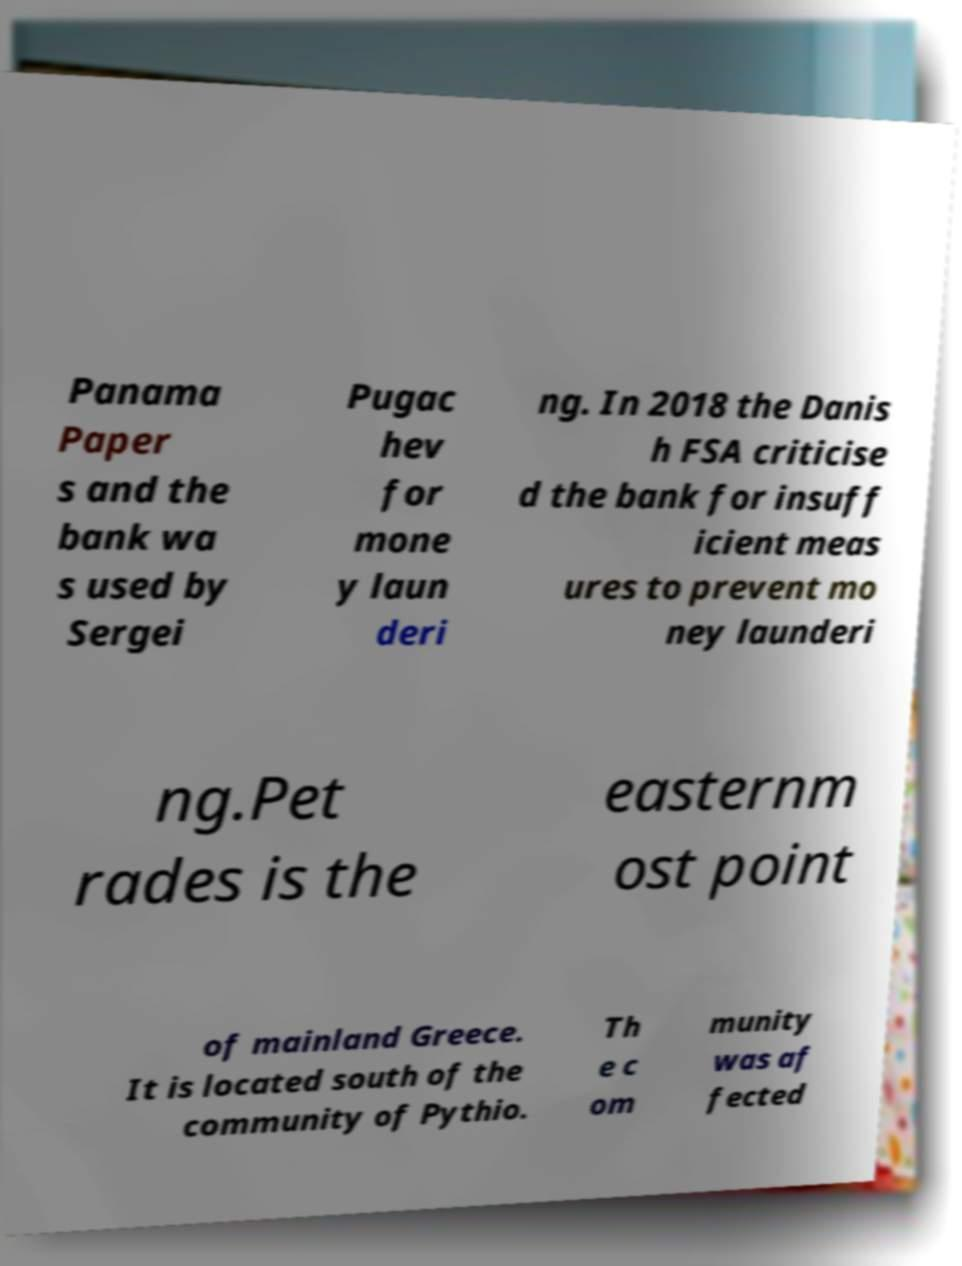Please identify and transcribe the text found in this image. Panama Paper s and the bank wa s used by Sergei Pugac hev for mone y laun deri ng. In 2018 the Danis h FSA criticise d the bank for insuff icient meas ures to prevent mo ney launderi ng.Pet rades is the easternm ost point of mainland Greece. It is located south of the community of Pythio. Th e c om munity was af fected 